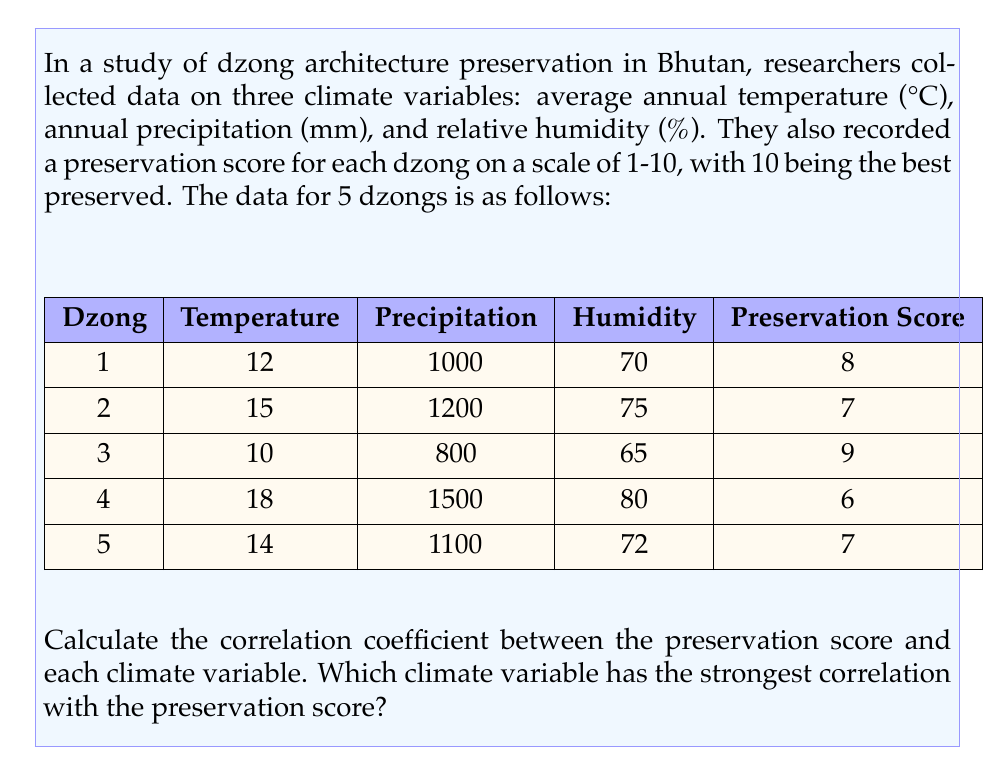What is the answer to this math problem? To solve this problem, we need to calculate the correlation coefficient between the preservation score and each of the climate variables. We'll use the Pearson correlation coefficient formula:

$$r_{xy} = \frac{\sum_{i=1}^{n} (x_i - \bar{x})(y_i - \bar{y})}{\sqrt{\sum_{i=1}^{n} (x_i - \bar{x})^2} \sqrt{\sum_{i=1}^{n} (y_i - \bar{y})^2}}$$

Where $x$ is the climate variable and $y$ is the preservation score.

Let's calculate the correlation for each climate variable:

1. Temperature vs. Preservation Score:

First, calculate the means:
$\bar{x} = \frac{12 + 15 + 10 + 18 + 14}{5} = 13.8$
$\bar{y} = \frac{8 + 7 + 9 + 6 + 7}{5} = 7.4$

Now, calculate the numerator and denominator:

$$\sum_{i=1}^{n} (x_i - \bar{x})(y_i - \bar{y}) = -7.92$$
$$\sqrt{\sum_{i=1}^{n} (x_i - \bar{x})^2} = 5.72$$
$$\sqrt{\sum_{i=1}^{n} (y_i - \bar{y})^2} = 2.24$$

The correlation coefficient for temperature is:
$$r_{\text{temp}} = \frac{-7.92}{5.72 \times 2.24} = -0.617$$

2. Precipitation vs. Preservation Score:

Following the same process:
$$r_{\text{precip}} = -0.913$$

3. Humidity vs. Preservation Score:

Again, using the same method:
$$r_{\text{humid}} = -0.954$$

The absolute values of these correlation coefficients are:
|$r_{\text{temp}}$| = 0.617
|$r_{\text{precip}}$| = 0.913
|$r_{\text{humid}}$| = 0.954

The largest absolute value indicates the strongest correlation.
Answer: The climate variable with the strongest correlation to the preservation score is humidity, with a correlation coefficient of -0.954. 